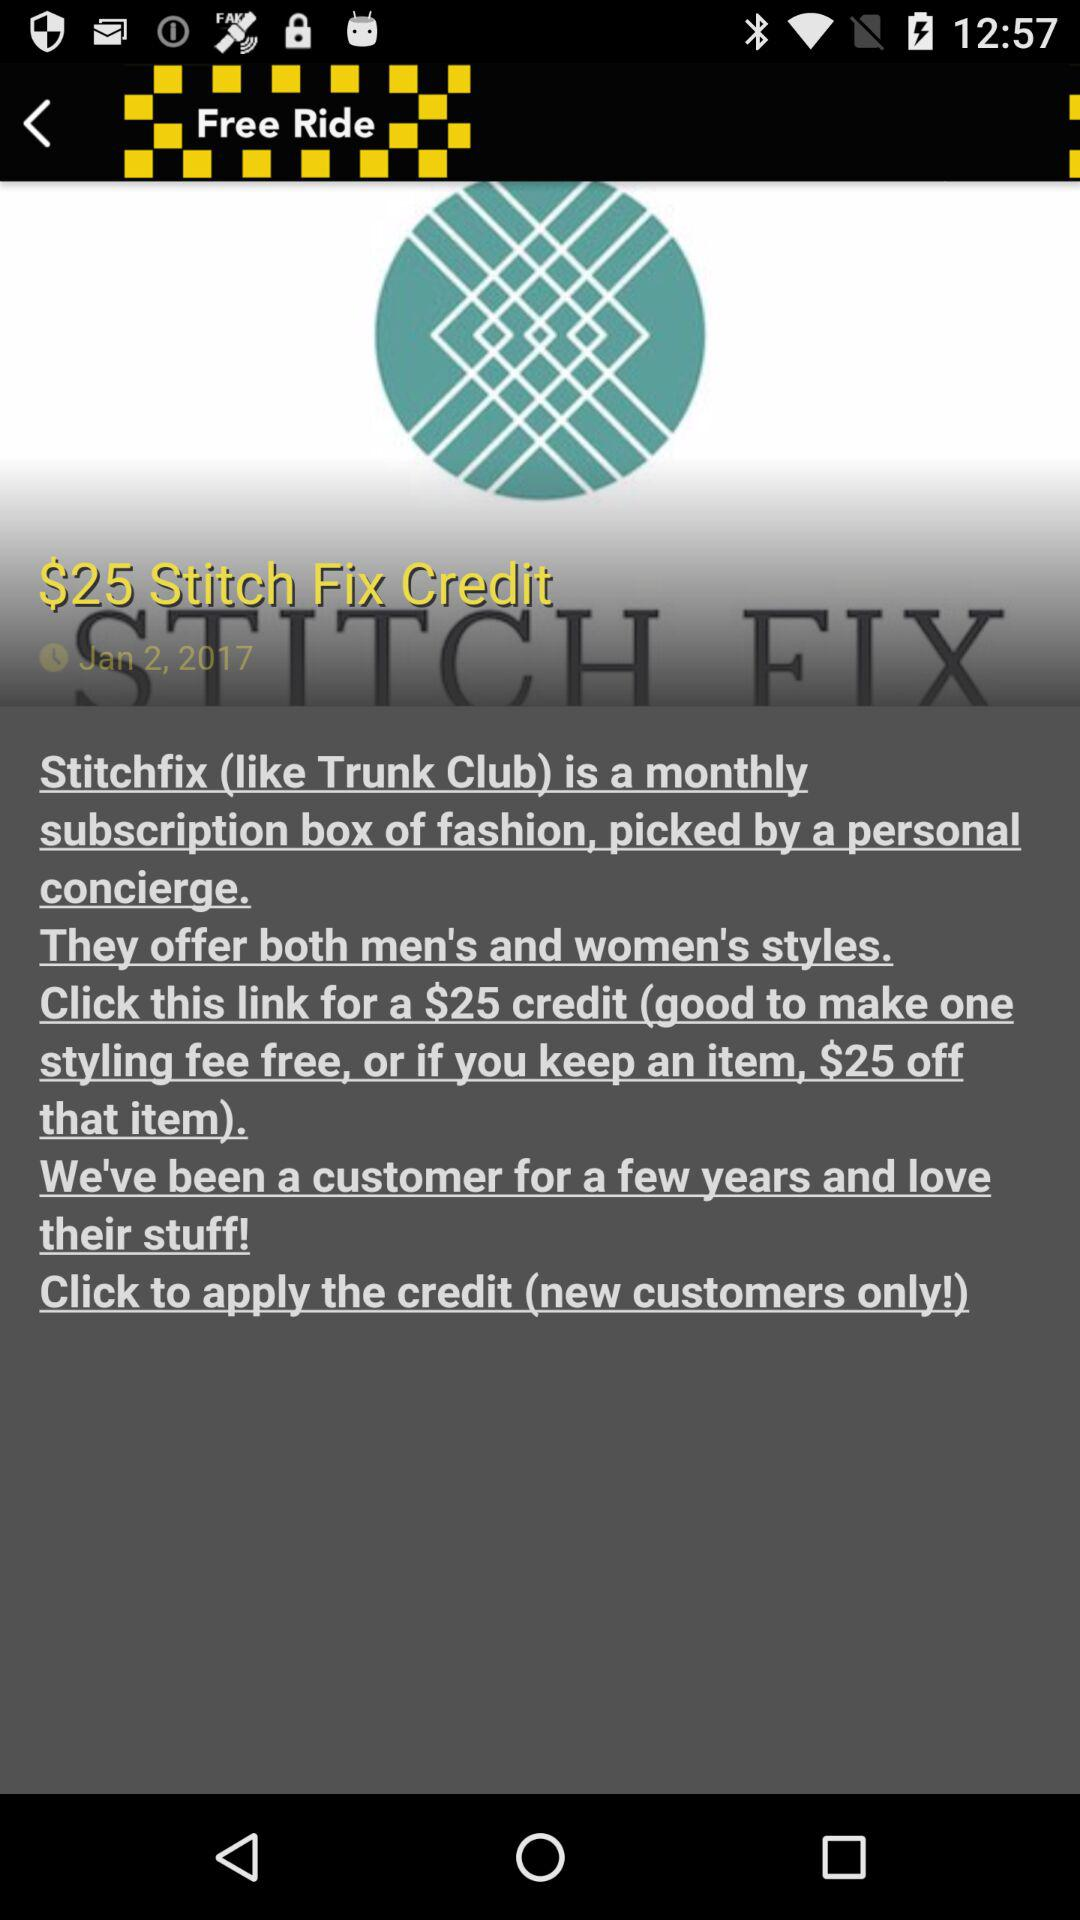How much money is credit? There is a $25 credit. 